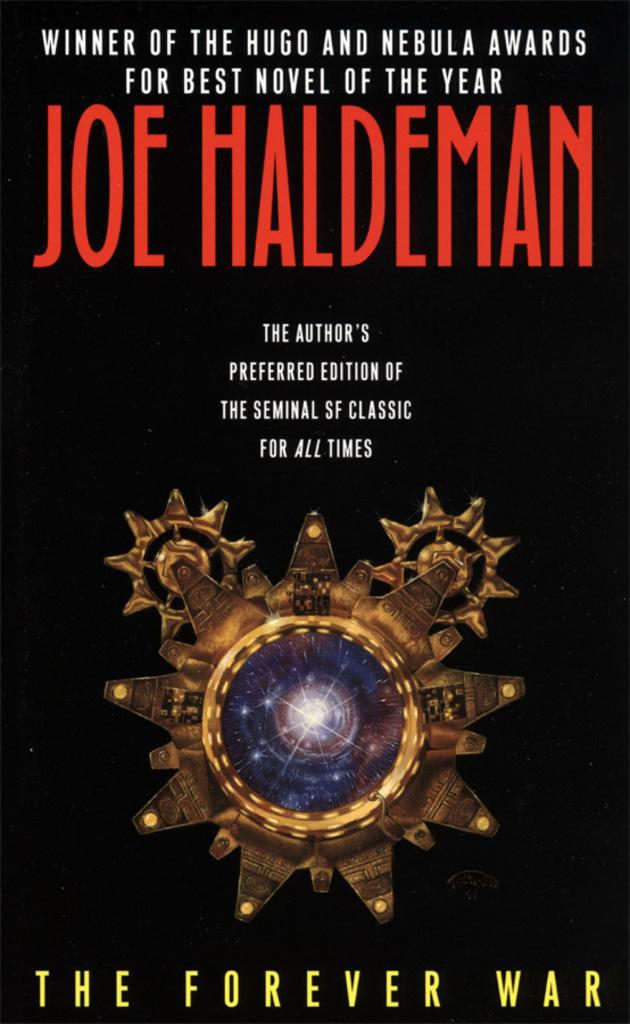<image>
Present a compact description of the photo's key features. Joe Haldeman The Forever War book which is the winner of the hugo and nebula awards. 